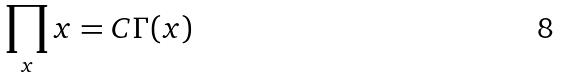Convert formula to latex. <formula><loc_0><loc_0><loc_500><loc_500>\prod _ { x } x = C \Gamma ( x )</formula> 